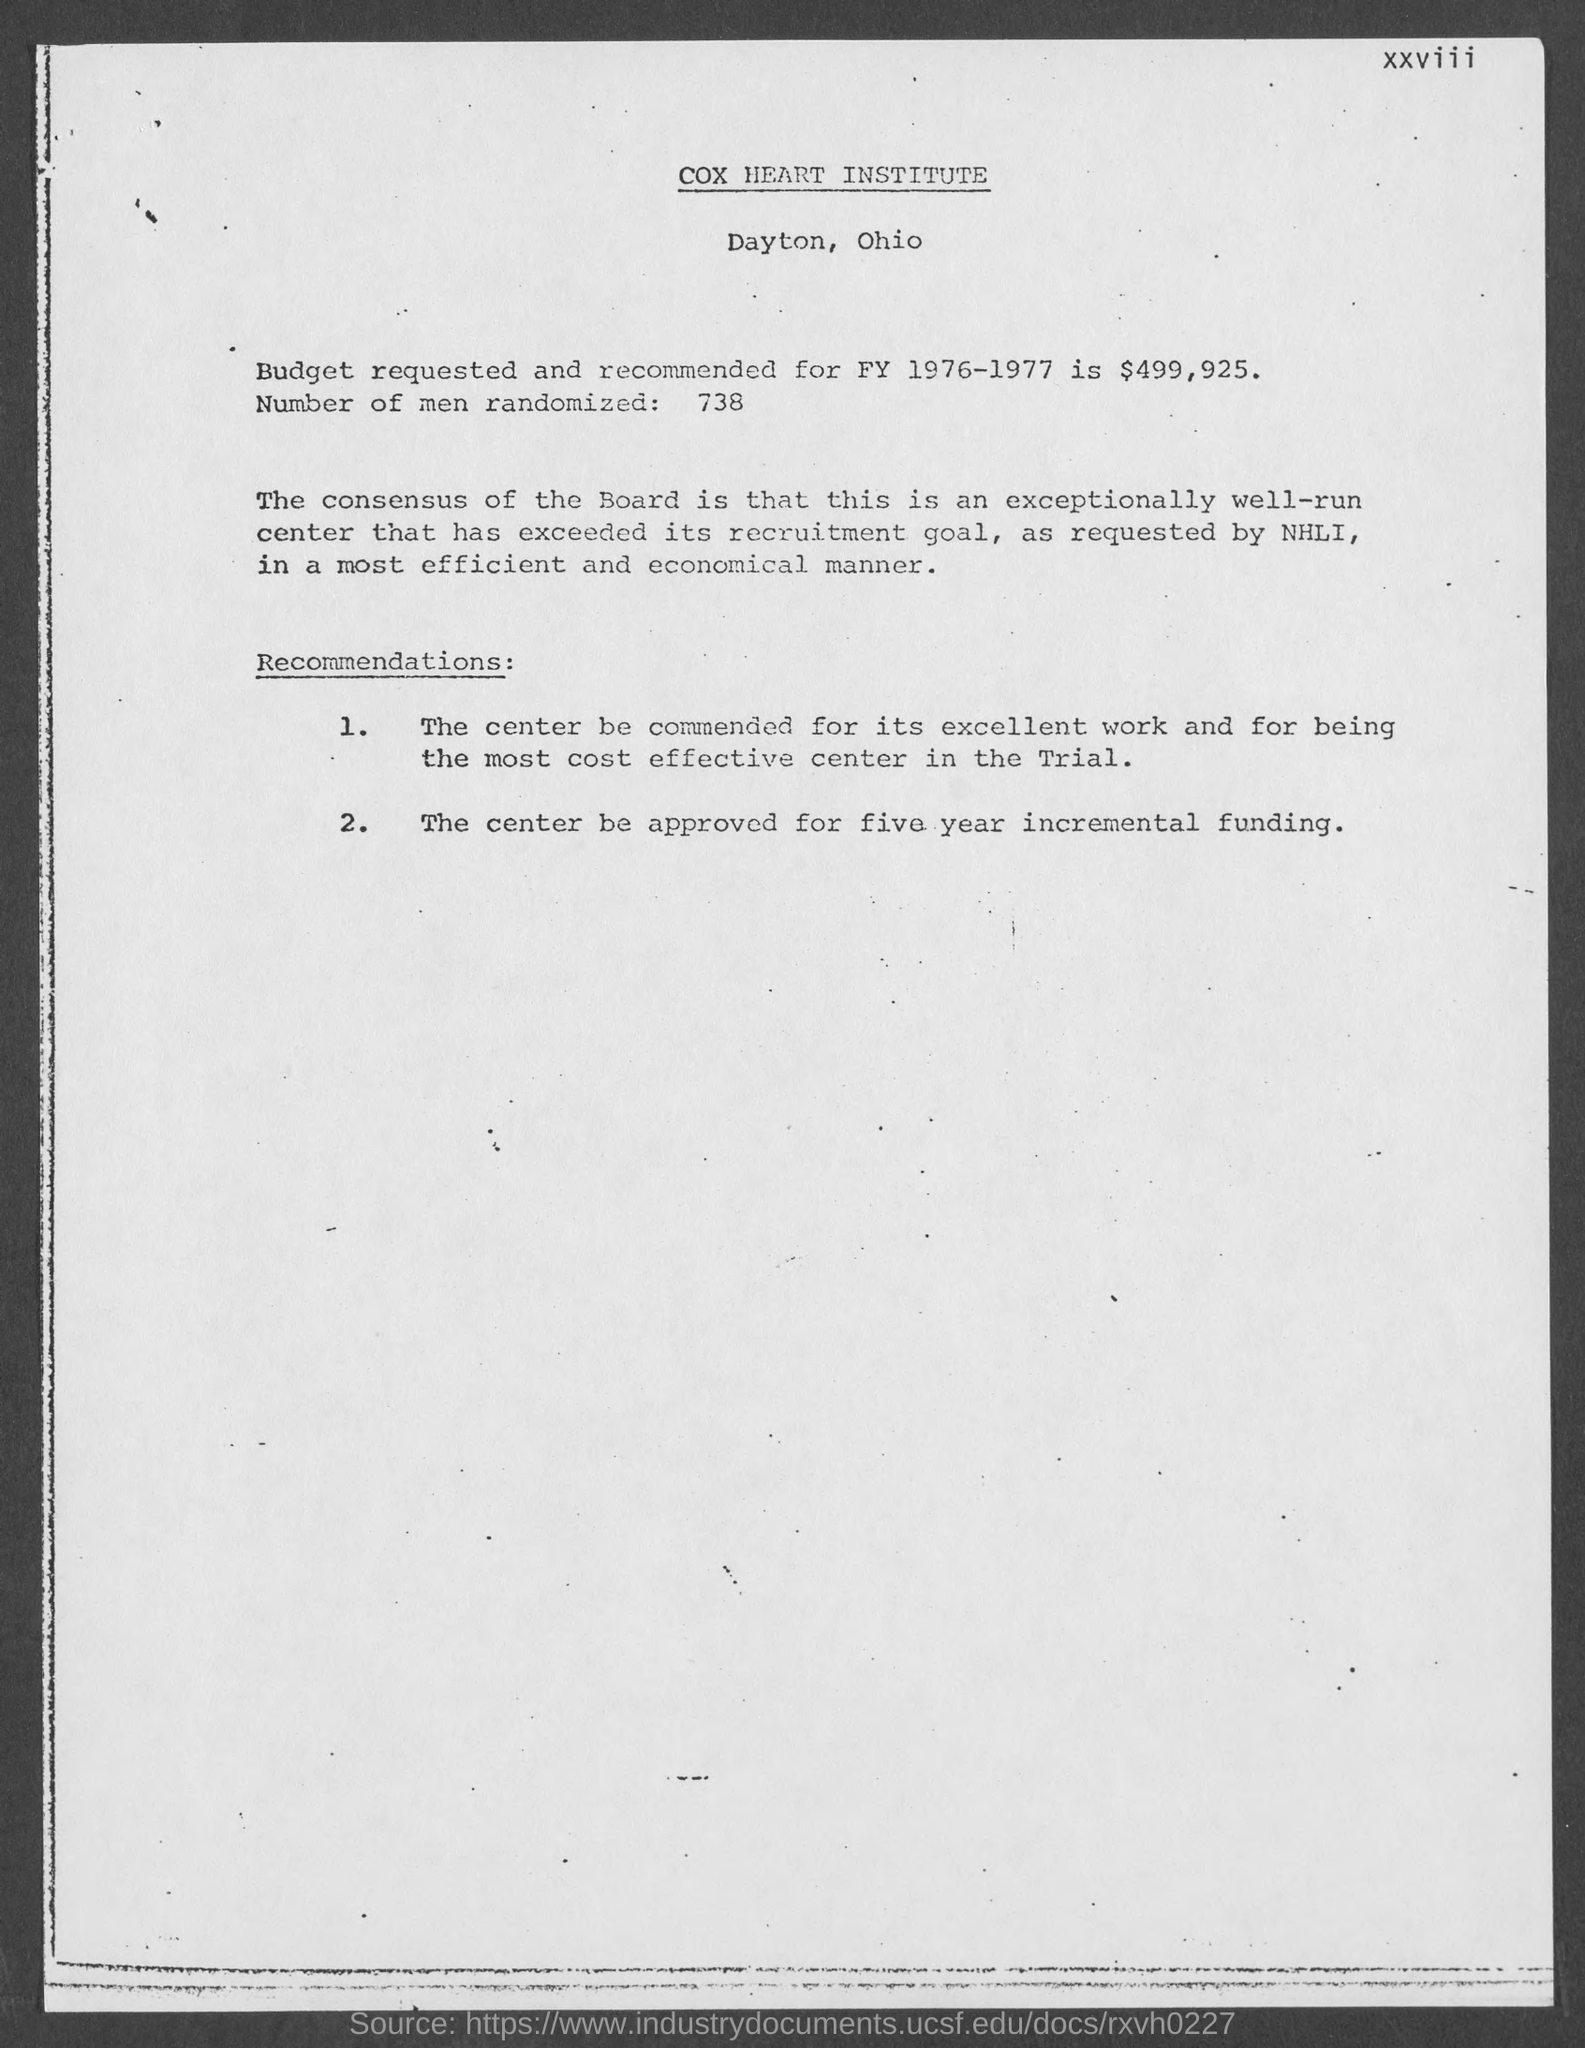Identify some key points in this picture. Seventy-three men were randomly selected for this study. The Cox Heart Institute is located in Dayton, Ohio. The Cox Heart Institute is the name of the institute. The amount requested and recommended for FY 1976-1977 is $499,925. 